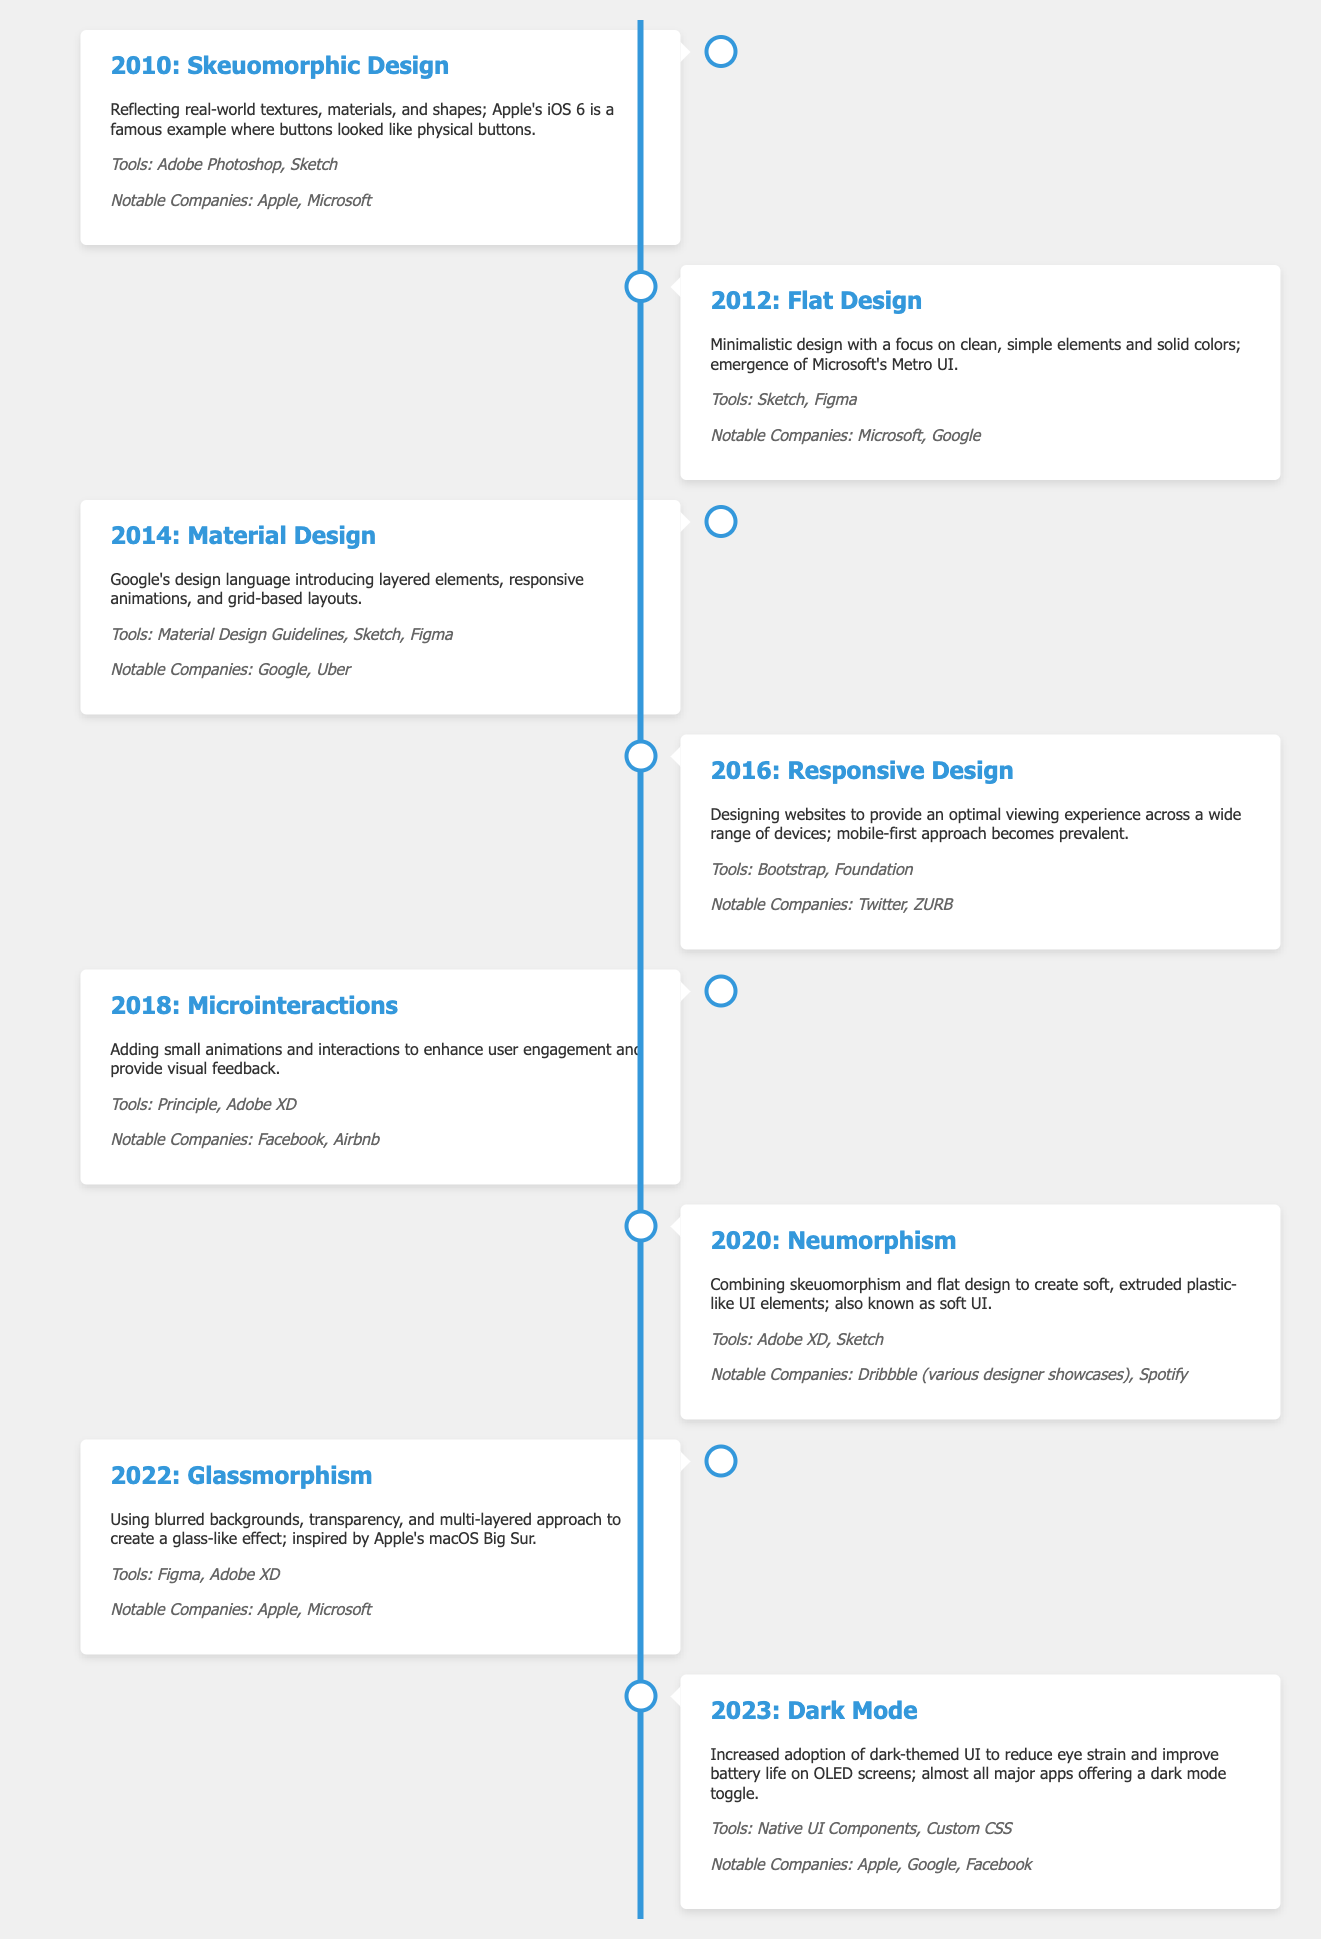What design trend was popular in 2010? The document states that the design trend popular in 2010 was Skeuomorphic Design.
Answer: Skeuomorphic Design Which design language was introduced by Google in 2014? According to the document, the design language introduced by Google in 2014 is Material Design.
Answer: Material Design What year did Flat Design emerge? The document indicates that Flat Design emerged in 2012.
Answer: 2012 Which notable companies are associated with Neumorphism? The document lists Dribbble (various designer showcases) and Spotify as notable companies associated with Neumorphism.
Answer: Dribbble, Spotify What tools were commonly used for Microinteractions in 2018? The document mentions Principle and Adobe XD as tools commonly used for Microinteractions in 2018.
Answer: Principle, Adobe XD How has the UI design trend evolved from 2010 to 2023? By examining the timeline, users can analyze that the design trends evolved from skeuomorphic to more minimalistic and functional designs such as Dark Mode.
Answer: From Skeuomorphic to Dark Mode What unique visual effect is used in Glassmorphism? The document states that Glassmorphism uses blurred backgrounds and transparency to create a glass-like effect.
Answer: Blurred backgrounds and transparency What is the main feature of Responsive Design? The document indicates that the main feature of Responsive Design is optimal viewing experience across devices.
Answer: Optimal viewing experience across devices Which design trend focuses on small animations for user engagement? The document specifies that the design trend focusing on small animations for user engagement is Microinteractions.
Answer: Microinteractions 